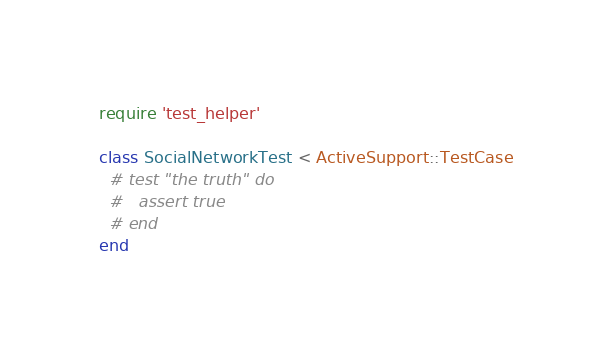Convert code to text. <code><loc_0><loc_0><loc_500><loc_500><_Ruby_>require 'test_helper'

class SocialNetworkTest < ActiveSupport::TestCase
  # test "the truth" do
  #   assert true
  # end
end
</code> 